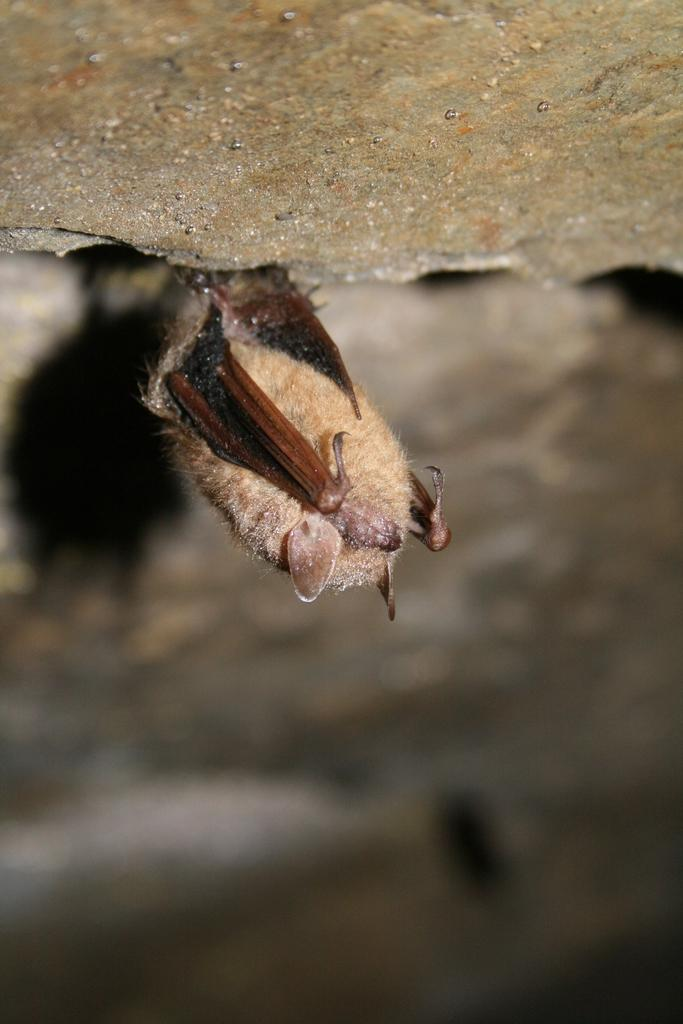What is the main subject of the image? The main subject of the image is an insect. Can you describe the location of the insect in the image? The insect is at the center of the image. What type of rake is being used to adjust the pot in the image? There is no rake or pot present in the image; it only features an insect at the center. 